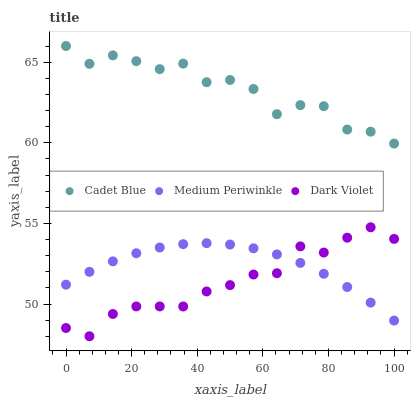Does Dark Violet have the minimum area under the curve?
Answer yes or no. Yes. Does Cadet Blue have the maximum area under the curve?
Answer yes or no. Yes. Does Medium Periwinkle have the minimum area under the curve?
Answer yes or no. No. Does Medium Periwinkle have the maximum area under the curve?
Answer yes or no. No. Is Medium Periwinkle the smoothest?
Answer yes or no. Yes. Is Cadet Blue the roughest?
Answer yes or no. Yes. Is Dark Violet the smoothest?
Answer yes or no. No. Is Dark Violet the roughest?
Answer yes or no. No. Does Dark Violet have the lowest value?
Answer yes or no. Yes. Does Medium Periwinkle have the lowest value?
Answer yes or no. No. Does Cadet Blue have the highest value?
Answer yes or no. Yes. Does Dark Violet have the highest value?
Answer yes or no. No. Is Medium Periwinkle less than Cadet Blue?
Answer yes or no. Yes. Is Cadet Blue greater than Medium Periwinkle?
Answer yes or no. Yes. Does Dark Violet intersect Medium Periwinkle?
Answer yes or no. Yes. Is Dark Violet less than Medium Periwinkle?
Answer yes or no. No. Is Dark Violet greater than Medium Periwinkle?
Answer yes or no. No. Does Medium Periwinkle intersect Cadet Blue?
Answer yes or no. No. 